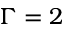<formula> <loc_0><loc_0><loc_500><loc_500>\Gamma = 2</formula> 